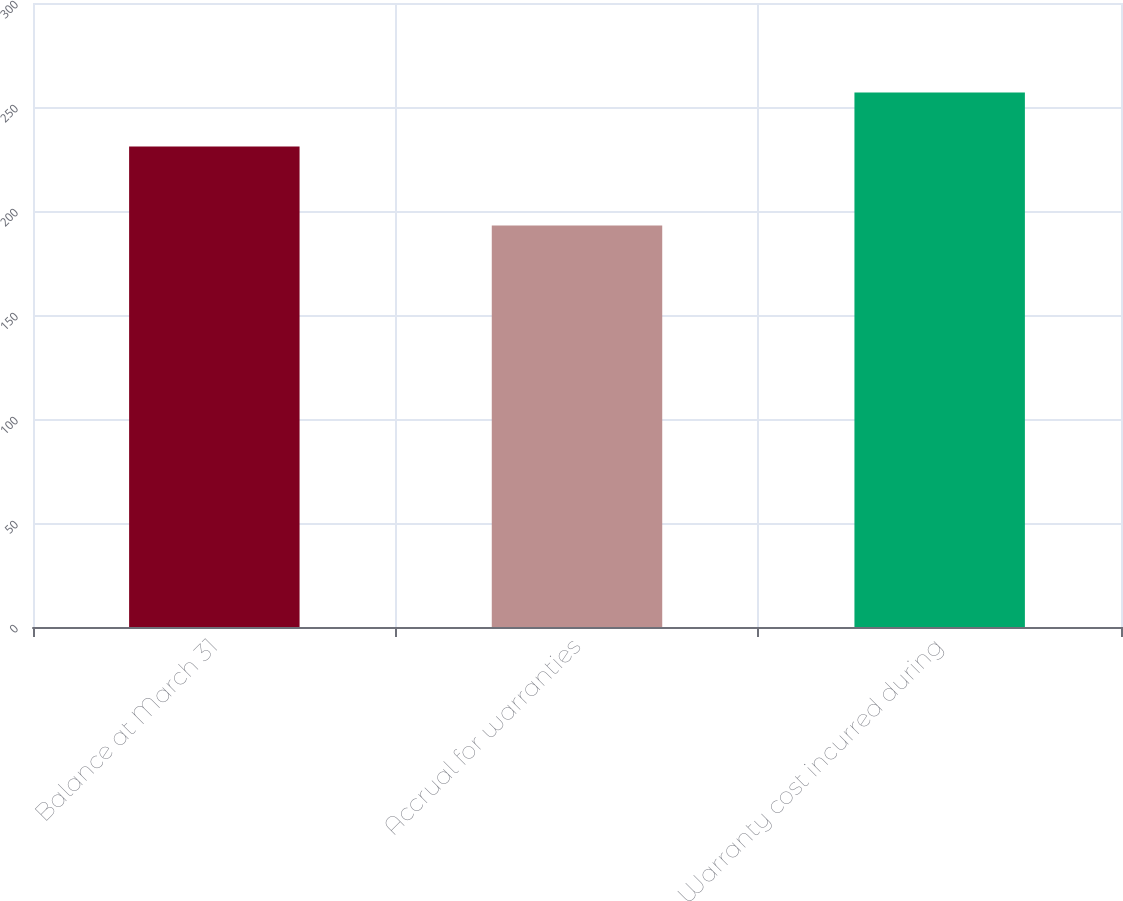Convert chart to OTSL. <chart><loc_0><loc_0><loc_500><loc_500><bar_chart><fcel>Balance at March 31<fcel>Accrual for warranties<fcel>Warranty cost incurred during<nl><fcel>231<fcel>193<fcel>257<nl></chart> 